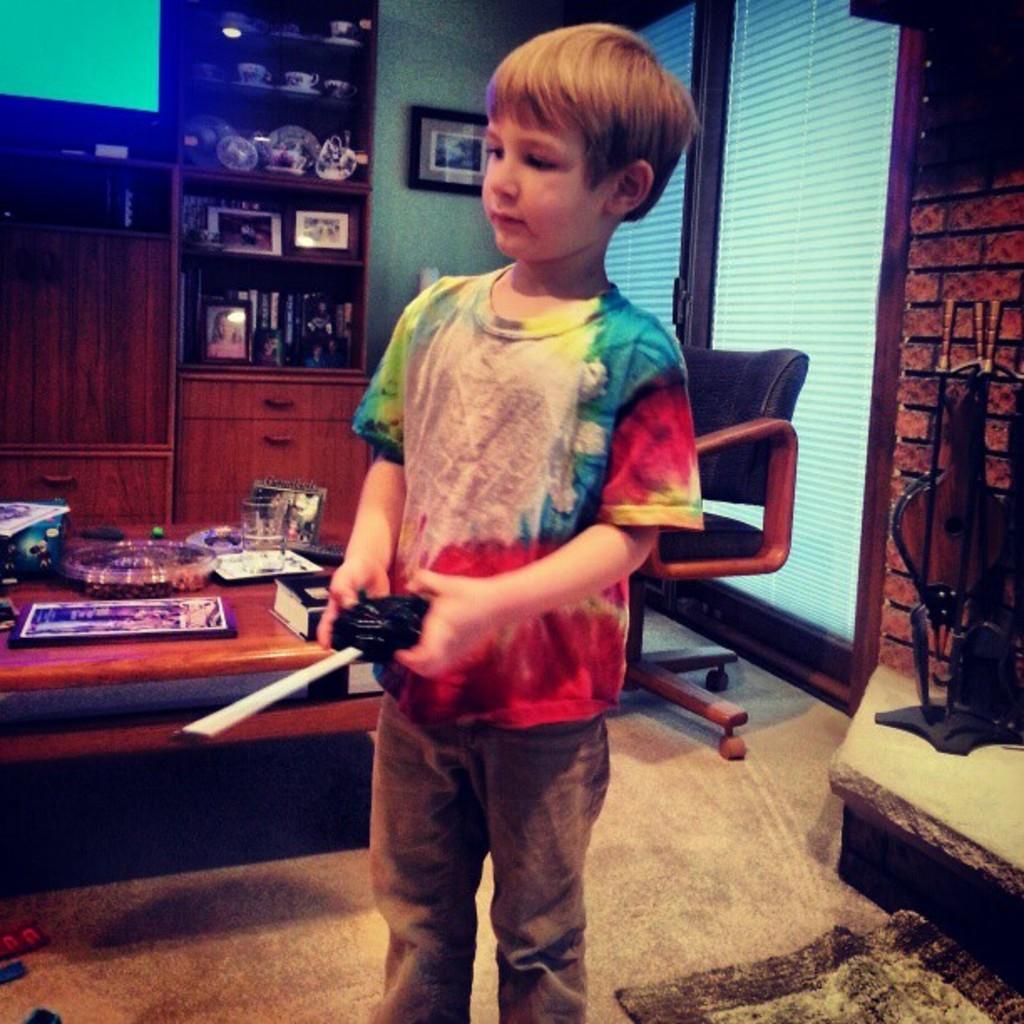How would you summarize this image in a sentence or two? This is the boy standing and holding some black color object in his hands. This is the table with a book,tumblr,frame and some objects on it. This is an empty chair. I can see some object placed here. At background I can see a rack with photo frames,books,cup and some ceramic items. This is the photo frame attached to the wall. These are the drawers. This looks like a door with a door lock. 